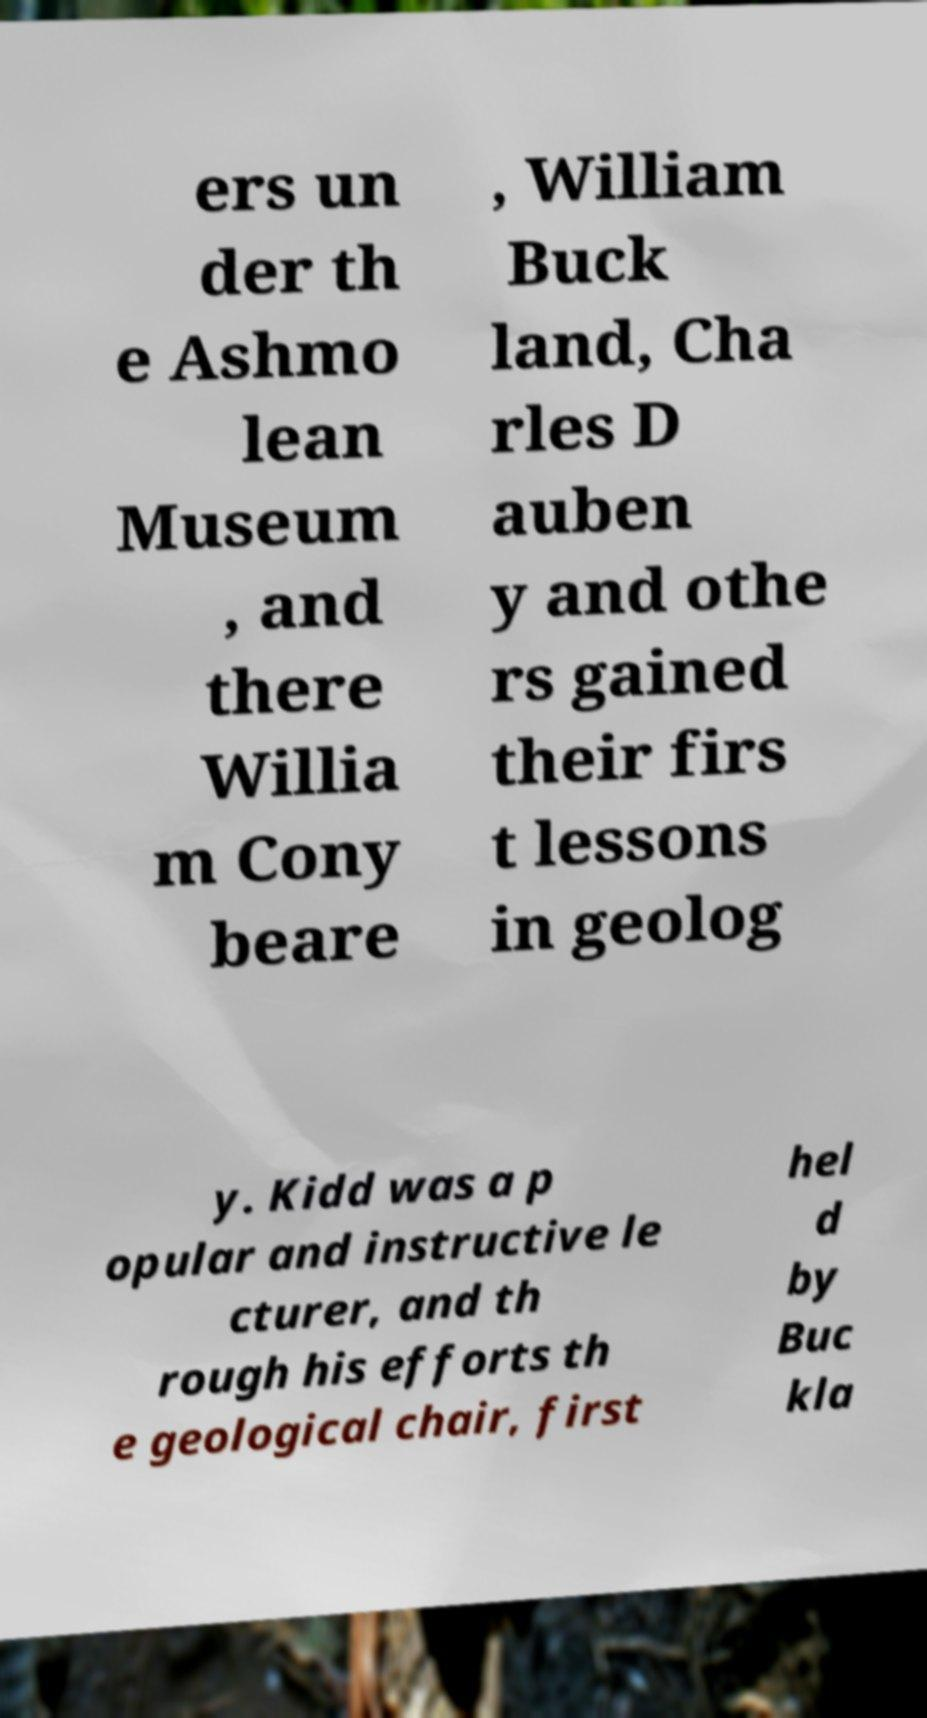Please identify and transcribe the text found in this image. ers un der th e Ashmo lean Museum , and there Willia m Cony beare , William Buck land, Cha rles D auben y and othe rs gained their firs t lessons in geolog y. Kidd was a p opular and instructive le cturer, and th rough his efforts th e geological chair, first hel d by Buc kla 